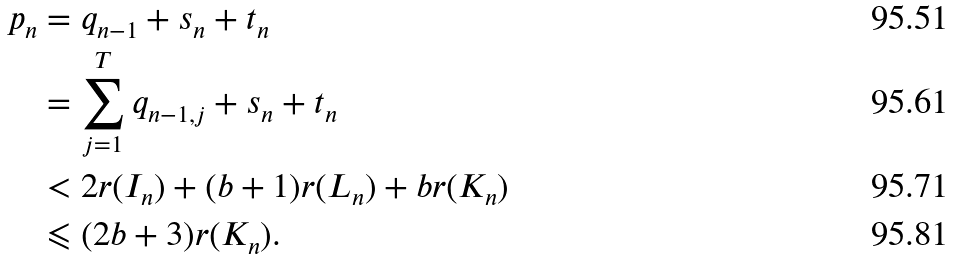<formula> <loc_0><loc_0><loc_500><loc_500>p _ { n } & = q _ { n - 1 } + s _ { n } + t _ { n } \\ & = \sum _ { j = 1 } ^ { T } q _ { n - 1 , j } + s _ { n } + t _ { n } \\ & < 2 r ( I _ { n } ) + ( b + 1 ) r ( L _ { n } ) + b r ( K _ { n } ) \\ & \leqslant ( 2 b + 3 ) r ( K _ { n } ) .</formula> 